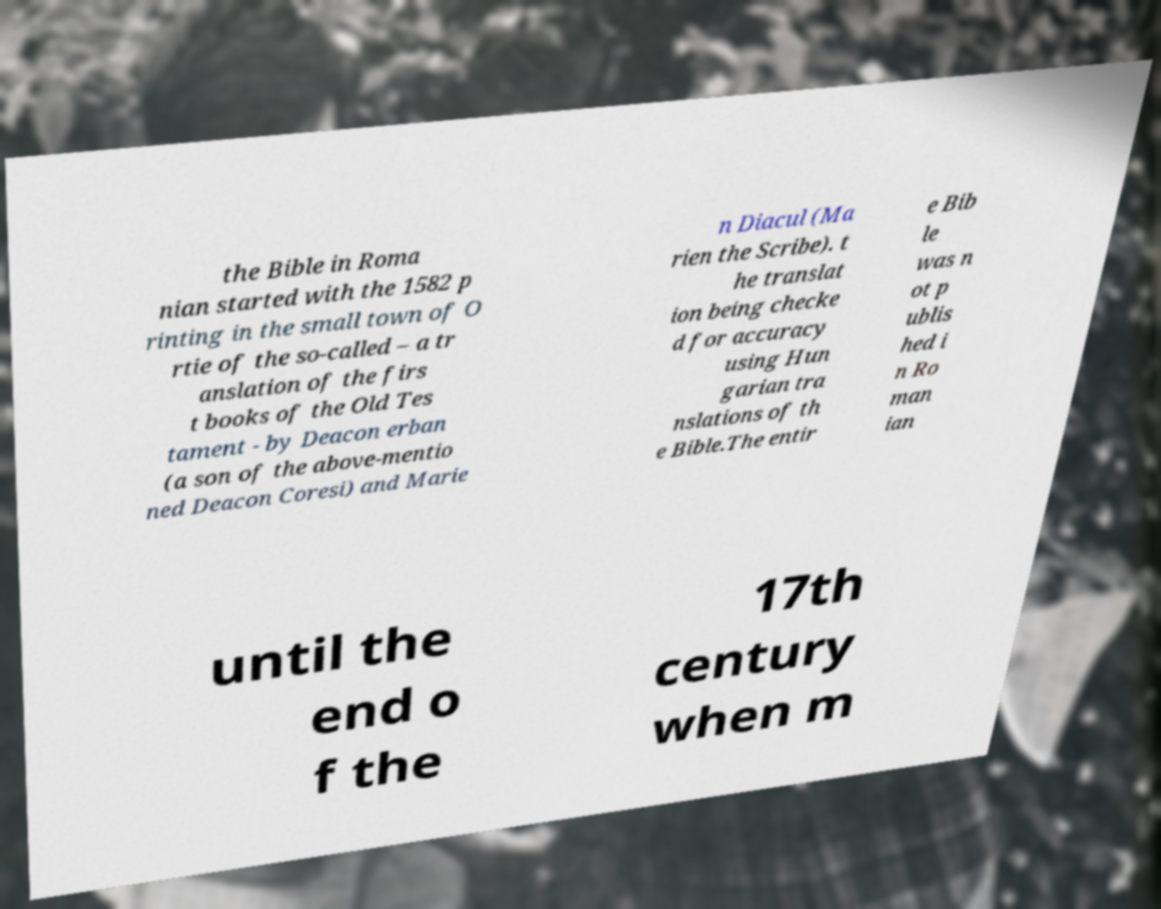Could you assist in decoding the text presented in this image and type it out clearly? the Bible in Roma nian started with the 1582 p rinting in the small town of O rtie of the so-called – a tr anslation of the firs t books of the Old Tes tament - by Deacon erban (a son of the above-mentio ned Deacon Coresi) and Marie n Diacul (Ma rien the Scribe). t he translat ion being checke d for accuracy using Hun garian tra nslations of th e Bible.The entir e Bib le was n ot p ublis hed i n Ro man ian until the end o f the 17th century when m 